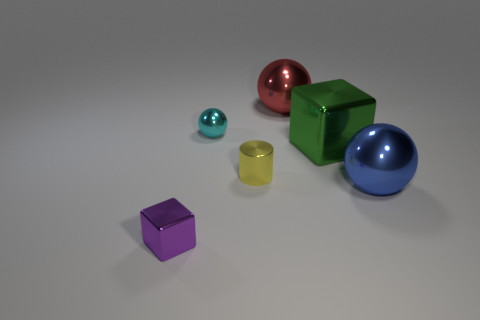Subtract all small metallic spheres. How many spheres are left? 2 Add 3 spheres. How many objects exist? 9 Subtract all purple blocks. How many blocks are left? 1 Add 6 large red objects. How many large red objects are left? 7 Add 5 small balls. How many small balls exist? 6 Subtract 0 red cylinders. How many objects are left? 6 Subtract all blocks. How many objects are left? 4 Subtract 1 blocks. How many blocks are left? 1 Subtract all brown blocks. Subtract all purple balls. How many blocks are left? 2 Subtract all objects. Subtract all blue cylinders. How many objects are left? 0 